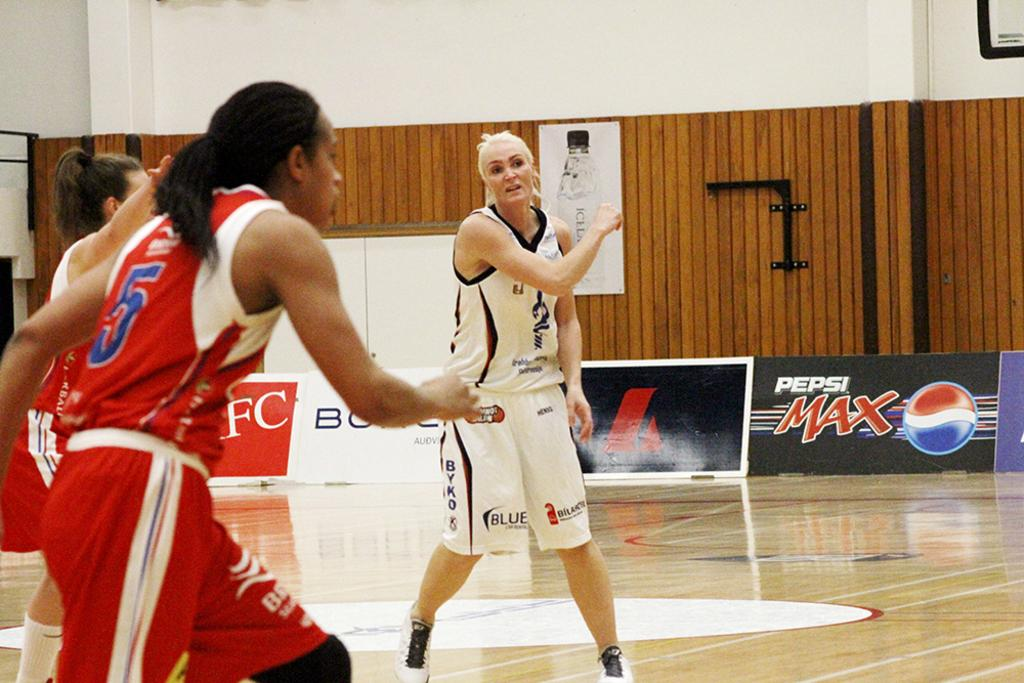<image>
Share a concise interpretation of the image provided. three girls are playing basketball on a court sponsored by Pepsi Max 